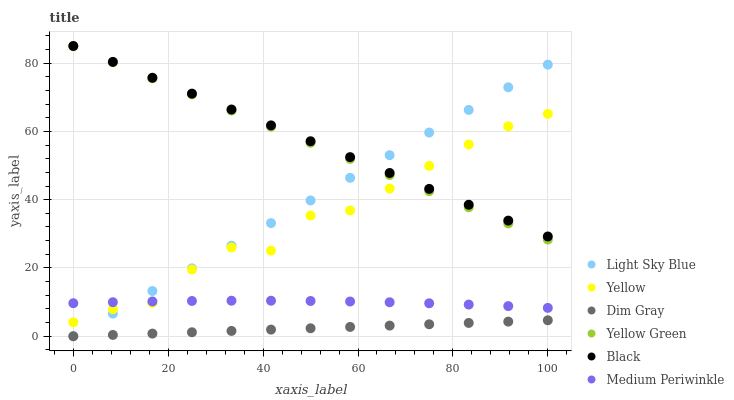Does Dim Gray have the minimum area under the curve?
Answer yes or no. Yes. Does Black have the maximum area under the curve?
Answer yes or no. Yes. Does Yellow Green have the minimum area under the curve?
Answer yes or no. No. Does Yellow Green have the maximum area under the curve?
Answer yes or no. No. Is Dim Gray the smoothest?
Answer yes or no. Yes. Is Yellow the roughest?
Answer yes or no. Yes. Is Yellow Green the smoothest?
Answer yes or no. No. Is Yellow Green the roughest?
Answer yes or no. No. Does Dim Gray have the lowest value?
Answer yes or no. Yes. Does Yellow Green have the lowest value?
Answer yes or no. No. Does Black have the highest value?
Answer yes or no. Yes. Does Medium Periwinkle have the highest value?
Answer yes or no. No. Is Dim Gray less than Medium Periwinkle?
Answer yes or no. Yes. Is Medium Periwinkle greater than Dim Gray?
Answer yes or no. Yes. Does Yellow intersect Medium Periwinkle?
Answer yes or no. Yes. Is Yellow less than Medium Periwinkle?
Answer yes or no. No. Is Yellow greater than Medium Periwinkle?
Answer yes or no. No. Does Dim Gray intersect Medium Periwinkle?
Answer yes or no. No. 